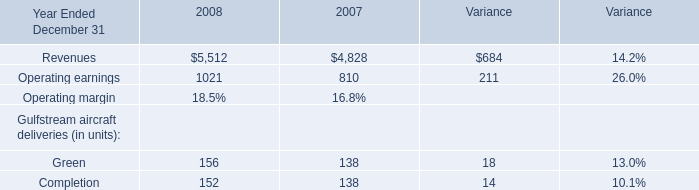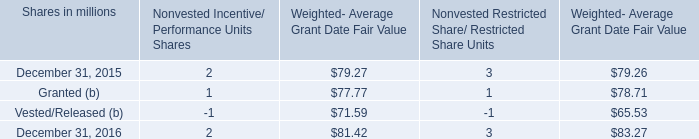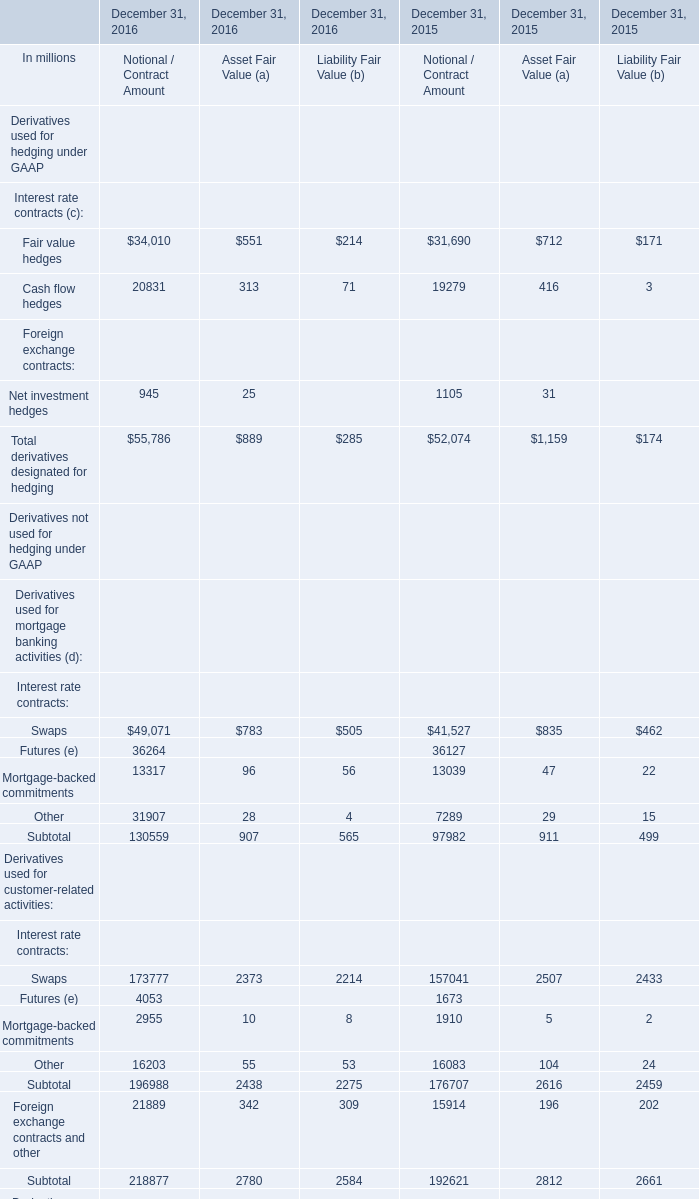What's the total amount of the Fair value hedges in the years where Fair value hedges is greater than 1 ? 
Computations: (34010 + 31690)
Answer: 65700.0. 